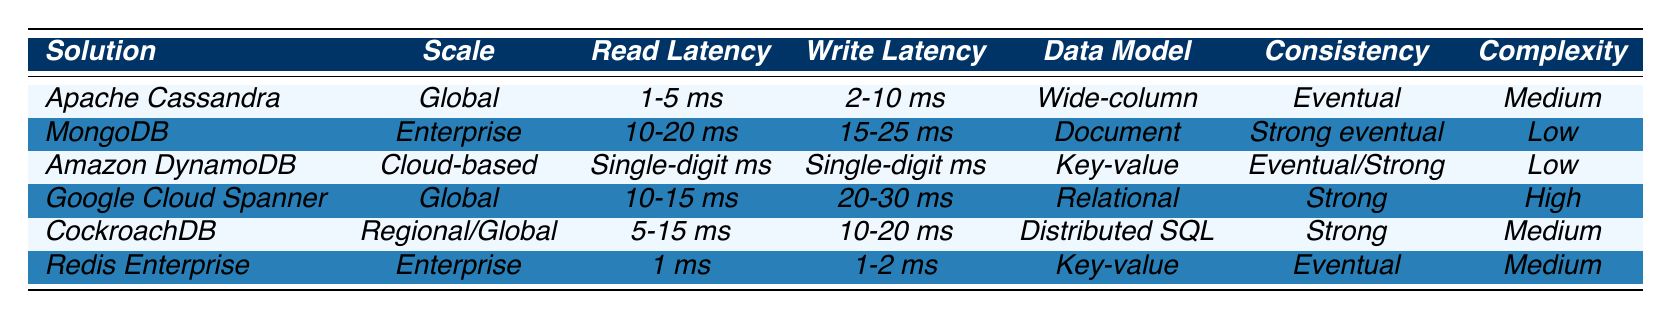What is the read latency for Redis Enterprise? According to the table, the read latency for Redis Enterprise is specified as 1 ms.
Answer: 1 ms Which database solutions have a setup complexity labeled as "Medium"? The table lists Apache Cassandra, CockroachDB, and Redis Enterprise as having a setup complexity of "Medium."
Answer: Apache Cassandra, CockroachDB, Redis Enterprise Is Amazon DynamoDB a cloud-based solution? The table indicates that Amazon DynamoDB is classified under "Cloud-based" deployment scale, confirming that it is indeed a cloud-based solution.
Answer: Yes What is the average write latency of the solutions with a "Strong consistency" model? The solutions with "Strong consistency" are Google Cloud Spanner (20-30 ms), CockroachDB (10-20 ms), and MongoDB (15-25 ms). The average for these is calculated as: (25 + 30 + 20 + 15 + 10) / 5 = 22 ms.
Answer: 22 ms Which database solution has the fastest read latency, and what is that latency? The table shows that Redis Enterprise has the fastest read latency of 1 ms among all the solutions.
Answer: Redis Enterprise, 1 ms Are there any database solutions with a read latency under 10 ms? The table shows that Apache Cassandra (1-5 ms) and Redis Enterprise (1 ms) have read latencies under 10 ms.
Answer: Yes What is the data model of Google Cloud Spanner? The table specifies that the data model of Google Cloud Spanner is "Relational with unique scalability."
Answer: Relational with unique scalability Which solutions have "Single-digit ms" for both read and write latencies? According to the table, Amazon DynamoDB is the only solution that specifies "Single-digit ms" for both read and write latencies.
Answer: Amazon DynamoDB How does the read latency of CockroachDB compare to that of MongoDB? CockroachDB has a read latency of 5-15 ms, while MongoDB has a higher read latency of 10-20 ms; therefore, CockroachDB's read latency range is lower than that of MongoDB.
Answer: CockroachDB's latency is lower Which notable clients are associated with Apache Cassandra? The table lists notable clients of Apache Cassandra as Netflix, Spotify, and eBay.
Answer: Netflix, Spotify, eBay 